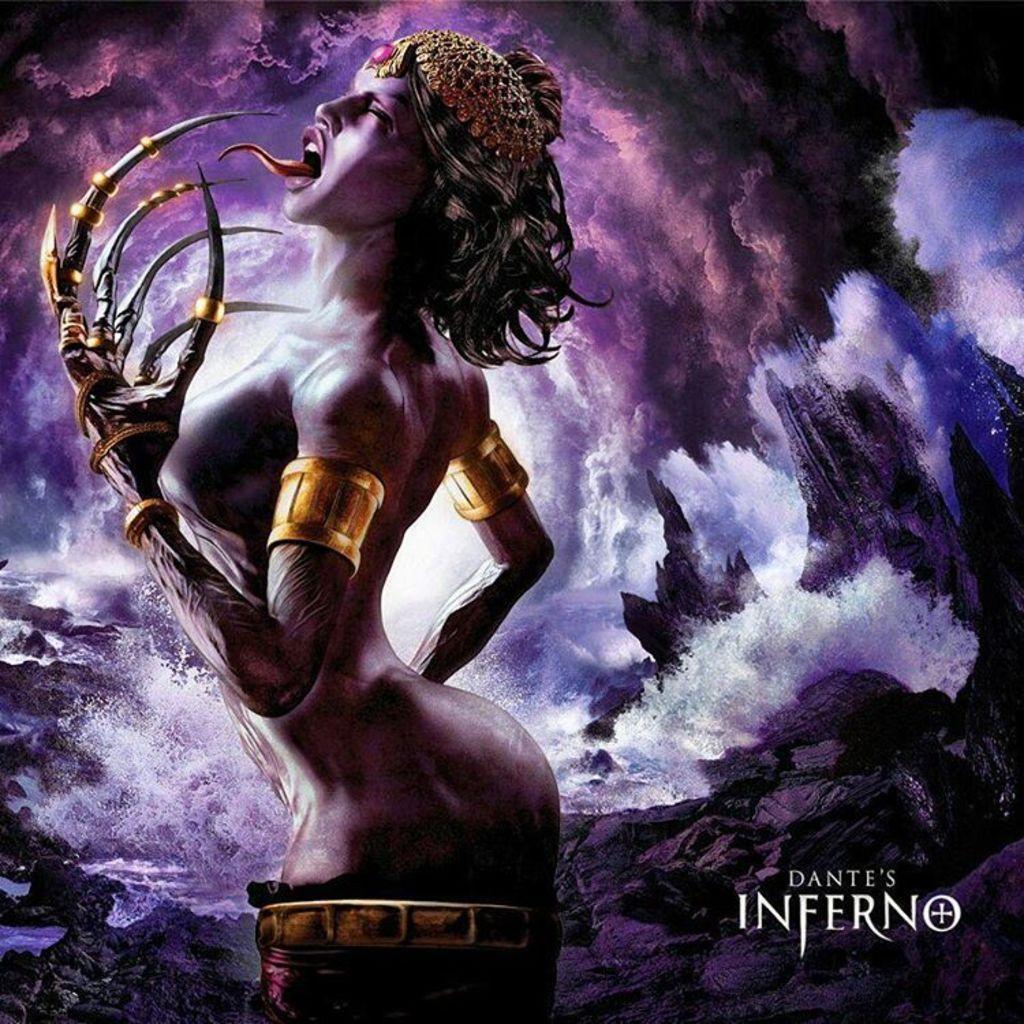Please provide a concise description of this image. This is a graphic image of a lady with demon hands and behind there is abstract of clouds and ocean. 